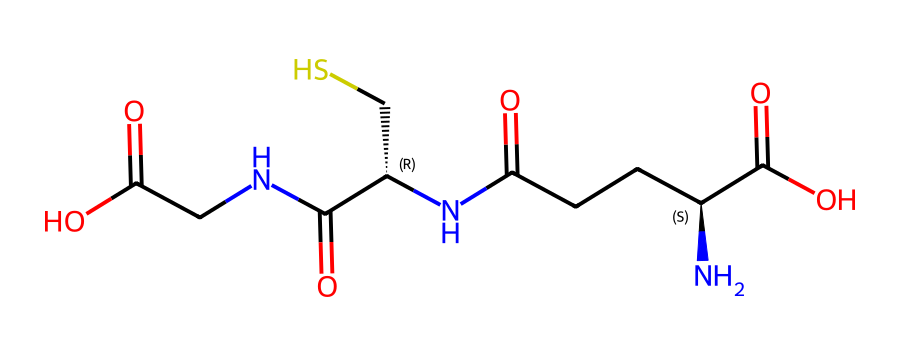What is the total number of carbon atoms in this chemical structure? In the SMILES representation, we can count the 'C' symbols. There are eight occurrences of 'C', which represent the carbon atoms in the molecule.
Answer: eight How many sulfur atoms are present in glutathione? In the given SMILES, the 'S' symbol indicates the presence of sulfur. There is one occurrence of 'S', signifying that there is only one sulfur atom in the glutathione structure.
Answer: one What functional groups can be identified in the glutathione structure? The structure contains multiple functional groups: amino (-NH2), carboxylic acid (-COOH), and thiol (-SH). These can be identified by their characteristic structures within the SMILES.
Answer: amino, carboxylic acid, thiol What is the role of sulfur in the chemical structure? Sulfur is present in the thiol group, contributing to the antioxidant properties of glutathione by providing a reactive site that can donate electrons.
Answer: antioxidant How many peptide bonds are present in this structure? Peptide bonds are formed between amino acids, identified by the sequences containing 'N' and 'C' together. In this SMILES representation, there are three distinct parts that show linkage through peptide bonds.
Answer: three What is the overall charge of the glutathione molecule at physiological pH? Considering the presence of functional groups and their likely charges at physiological pH, glutathione typically has a net negative charge due to the deprotonation of the carboxylic acid group.
Answer: negative 